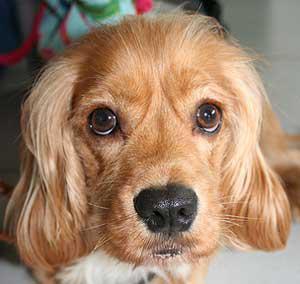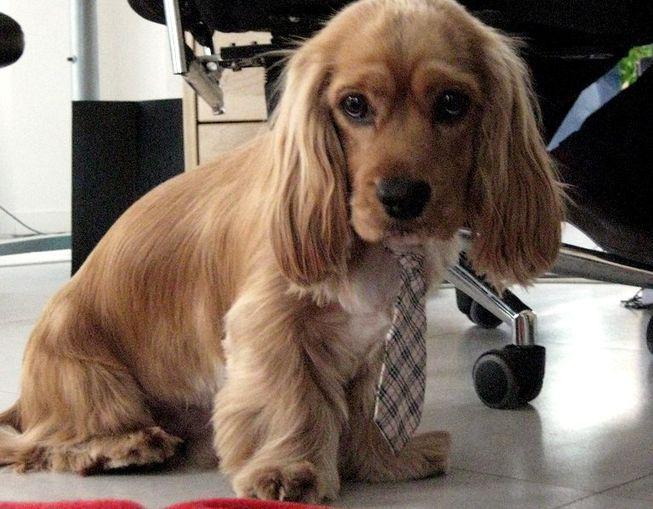The first image is the image on the left, the second image is the image on the right. Analyze the images presented: Is the assertion "The dog in the image on the right is sitting." valid? Answer yes or no. Yes. 